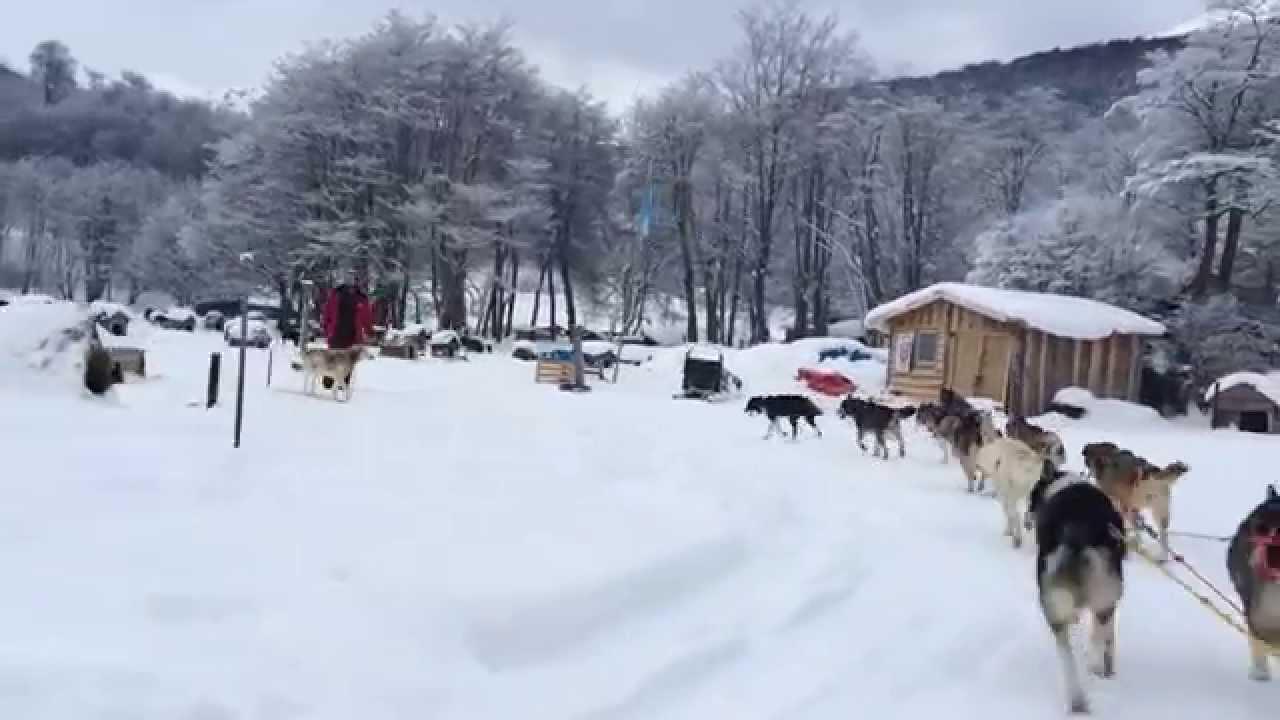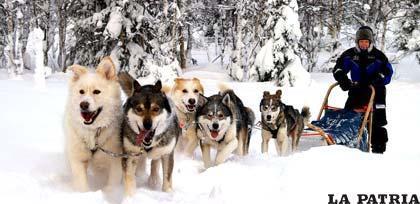The first image is the image on the left, the second image is the image on the right. Considering the images on both sides, is "An image shows a sled driver on the right behind a team of dogs facing the camera." valid? Answer yes or no. Yes. 